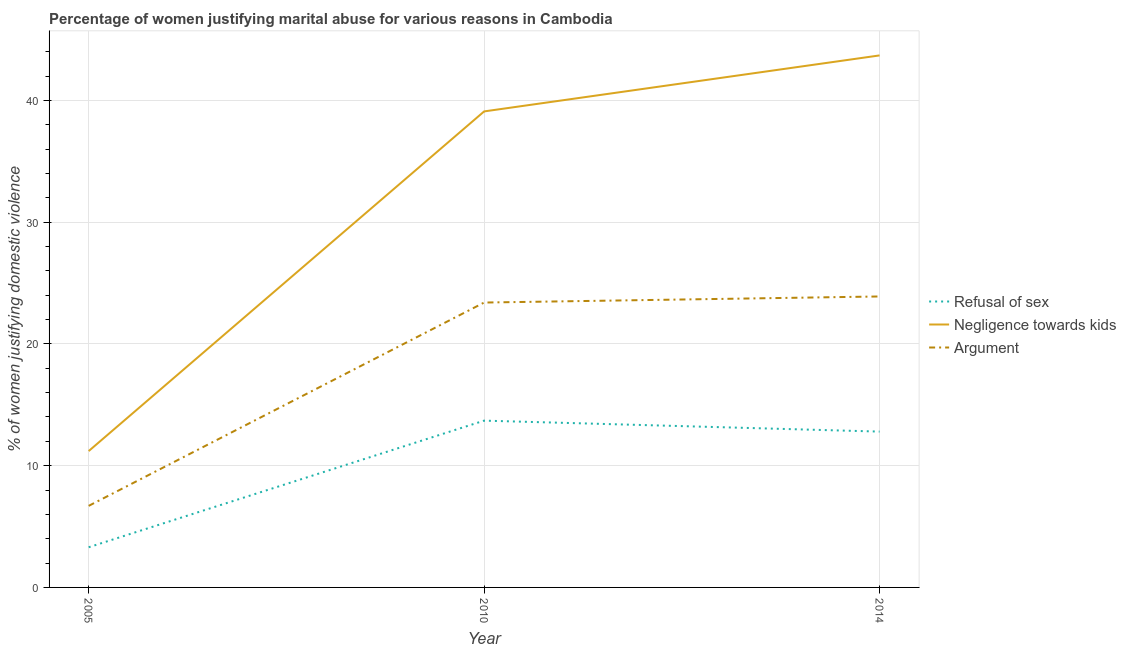Does the line corresponding to percentage of women justifying domestic violence due to negligence towards kids intersect with the line corresponding to percentage of women justifying domestic violence due to refusal of sex?
Keep it short and to the point. No. What is the percentage of women justifying domestic violence due to arguments in 2014?
Ensure brevity in your answer.  23.9. Across all years, what is the maximum percentage of women justifying domestic violence due to arguments?
Your response must be concise. 23.9. Across all years, what is the minimum percentage of women justifying domestic violence due to arguments?
Keep it short and to the point. 6.7. In which year was the percentage of women justifying domestic violence due to refusal of sex maximum?
Your response must be concise. 2010. In which year was the percentage of women justifying domestic violence due to refusal of sex minimum?
Give a very brief answer. 2005. What is the total percentage of women justifying domestic violence due to arguments in the graph?
Your answer should be compact. 54. What is the difference between the percentage of women justifying domestic violence due to negligence towards kids in 2005 and that in 2010?
Provide a succinct answer. -27.9. What is the difference between the percentage of women justifying domestic violence due to arguments in 2010 and the percentage of women justifying domestic violence due to negligence towards kids in 2014?
Offer a terse response. -20.3. What is the average percentage of women justifying domestic violence due to refusal of sex per year?
Your answer should be very brief. 9.93. In the year 2005, what is the difference between the percentage of women justifying domestic violence due to refusal of sex and percentage of women justifying domestic violence due to negligence towards kids?
Provide a succinct answer. -7.9. What is the ratio of the percentage of women justifying domestic violence due to negligence towards kids in 2005 to that in 2010?
Provide a short and direct response. 0.29. Is the difference between the percentage of women justifying domestic violence due to arguments in 2005 and 2014 greater than the difference between the percentage of women justifying domestic violence due to refusal of sex in 2005 and 2014?
Ensure brevity in your answer.  No. Is the sum of the percentage of women justifying domestic violence due to arguments in 2010 and 2014 greater than the maximum percentage of women justifying domestic violence due to negligence towards kids across all years?
Provide a succinct answer. Yes. How many lines are there?
Keep it short and to the point. 3. How many years are there in the graph?
Keep it short and to the point. 3. What is the difference between two consecutive major ticks on the Y-axis?
Provide a short and direct response. 10. Are the values on the major ticks of Y-axis written in scientific E-notation?
Provide a succinct answer. No. Does the graph contain grids?
Keep it short and to the point. Yes. Where does the legend appear in the graph?
Offer a very short reply. Center right. How many legend labels are there?
Your answer should be compact. 3. What is the title of the graph?
Provide a succinct answer. Percentage of women justifying marital abuse for various reasons in Cambodia. Does "Primary education" appear as one of the legend labels in the graph?
Your answer should be compact. No. What is the label or title of the X-axis?
Your response must be concise. Year. What is the label or title of the Y-axis?
Keep it short and to the point. % of women justifying domestic violence. What is the % of women justifying domestic violence of Refusal of sex in 2005?
Your answer should be compact. 3.3. What is the % of women justifying domestic violence of Argument in 2005?
Provide a short and direct response. 6.7. What is the % of women justifying domestic violence in Negligence towards kids in 2010?
Ensure brevity in your answer.  39.1. What is the % of women justifying domestic violence in Argument in 2010?
Make the answer very short. 23.4. What is the % of women justifying domestic violence in Refusal of sex in 2014?
Your answer should be very brief. 12.8. What is the % of women justifying domestic violence of Negligence towards kids in 2014?
Your answer should be compact. 43.7. What is the % of women justifying domestic violence of Argument in 2014?
Make the answer very short. 23.9. Across all years, what is the maximum % of women justifying domestic violence in Refusal of sex?
Provide a succinct answer. 13.7. Across all years, what is the maximum % of women justifying domestic violence in Negligence towards kids?
Provide a short and direct response. 43.7. Across all years, what is the maximum % of women justifying domestic violence in Argument?
Keep it short and to the point. 23.9. What is the total % of women justifying domestic violence in Refusal of sex in the graph?
Provide a short and direct response. 29.8. What is the total % of women justifying domestic violence in Negligence towards kids in the graph?
Your answer should be very brief. 94. What is the total % of women justifying domestic violence of Argument in the graph?
Make the answer very short. 54. What is the difference between the % of women justifying domestic violence of Negligence towards kids in 2005 and that in 2010?
Provide a short and direct response. -27.9. What is the difference between the % of women justifying domestic violence of Argument in 2005 and that in 2010?
Your response must be concise. -16.7. What is the difference between the % of women justifying domestic violence of Refusal of sex in 2005 and that in 2014?
Offer a terse response. -9.5. What is the difference between the % of women justifying domestic violence of Negligence towards kids in 2005 and that in 2014?
Your answer should be compact. -32.5. What is the difference between the % of women justifying domestic violence in Argument in 2005 and that in 2014?
Provide a short and direct response. -17.2. What is the difference between the % of women justifying domestic violence in Refusal of sex in 2010 and that in 2014?
Offer a terse response. 0.9. What is the difference between the % of women justifying domestic violence of Negligence towards kids in 2010 and that in 2014?
Provide a succinct answer. -4.6. What is the difference between the % of women justifying domestic violence of Refusal of sex in 2005 and the % of women justifying domestic violence of Negligence towards kids in 2010?
Provide a short and direct response. -35.8. What is the difference between the % of women justifying domestic violence of Refusal of sex in 2005 and the % of women justifying domestic violence of Argument in 2010?
Make the answer very short. -20.1. What is the difference between the % of women justifying domestic violence in Negligence towards kids in 2005 and the % of women justifying domestic violence in Argument in 2010?
Provide a succinct answer. -12.2. What is the difference between the % of women justifying domestic violence in Refusal of sex in 2005 and the % of women justifying domestic violence in Negligence towards kids in 2014?
Your response must be concise. -40.4. What is the difference between the % of women justifying domestic violence in Refusal of sex in 2005 and the % of women justifying domestic violence in Argument in 2014?
Offer a very short reply. -20.6. What is the difference between the % of women justifying domestic violence in Negligence towards kids in 2005 and the % of women justifying domestic violence in Argument in 2014?
Make the answer very short. -12.7. What is the difference between the % of women justifying domestic violence in Refusal of sex in 2010 and the % of women justifying domestic violence in Negligence towards kids in 2014?
Offer a terse response. -30. What is the difference between the % of women justifying domestic violence of Negligence towards kids in 2010 and the % of women justifying domestic violence of Argument in 2014?
Offer a terse response. 15.2. What is the average % of women justifying domestic violence in Refusal of sex per year?
Your answer should be compact. 9.93. What is the average % of women justifying domestic violence in Negligence towards kids per year?
Offer a terse response. 31.33. In the year 2005, what is the difference between the % of women justifying domestic violence in Refusal of sex and % of women justifying domestic violence in Negligence towards kids?
Provide a succinct answer. -7.9. In the year 2010, what is the difference between the % of women justifying domestic violence of Refusal of sex and % of women justifying domestic violence of Negligence towards kids?
Make the answer very short. -25.4. In the year 2010, what is the difference between the % of women justifying domestic violence in Negligence towards kids and % of women justifying domestic violence in Argument?
Ensure brevity in your answer.  15.7. In the year 2014, what is the difference between the % of women justifying domestic violence in Refusal of sex and % of women justifying domestic violence in Negligence towards kids?
Your answer should be compact. -30.9. In the year 2014, what is the difference between the % of women justifying domestic violence in Refusal of sex and % of women justifying domestic violence in Argument?
Provide a succinct answer. -11.1. In the year 2014, what is the difference between the % of women justifying domestic violence of Negligence towards kids and % of women justifying domestic violence of Argument?
Keep it short and to the point. 19.8. What is the ratio of the % of women justifying domestic violence in Refusal of sex in 2005 to that in 2010?
Provide a short and direct response. 0.24. What is the ratio of the % of women justifying domestic violence of Negligence towards kids in 2005 to that in 2010?
Provide a short and direct response. 0.29. What is the ratio of the % of women justifying domestic violence in Argument in 2005 to that in 2010?
Your answer should be very brief. 0.29. What is the ratio of the % of women justifying domestic violence in Refusal of sex in 2005 to that in 2014?
Provide a short and direct response. 0.26. What is the ratio of the % of women justifying domestic violence in Negligence towards kids in 2005 to that in 2014?
Offer a terse response. 0.26. What is the ratio of the % of women justifying domestic violence in Argument in 2005 to that in 2014?
Provide a short and direct response. 0.28. What is the ratio of the % of women justifying domestic violence in Refusal of sex in 2010 to that in 2014?
Your answer should be very brief. 1.07. What is the ratio of the % of women justifying domestic violence of Negligence towards kids in 2010 to that in 2014?
Your answer should be compact. 0.89. What is the ratio of the % of women justifying domestic violence in Argument in 2010 to that in 2014?
Provide a succinct answer. 0.98. What is the difference between the highest and the second highest % of women justifying domestic violence of Refusal of sex?
Offer a terse response. 0.9. What is the difference between the highest and the second highest % of women justifying domestic violence of Negligence towards kids?
Keep it short and to the point. 4.6. What is the difference between the highest and the lowest % of women justifying domestic violence of Refusal of sex?
Your answer should be compact. 10.4. What is the difference between the highest and the lowest % of women justifying domestic violence of Negligence towards kids?
Give a very brief answer. 32.5. What is the difference between the highest and the lowest % of women justifying domestic violence of Argument?
Provide a succinct answer. 17.2. 